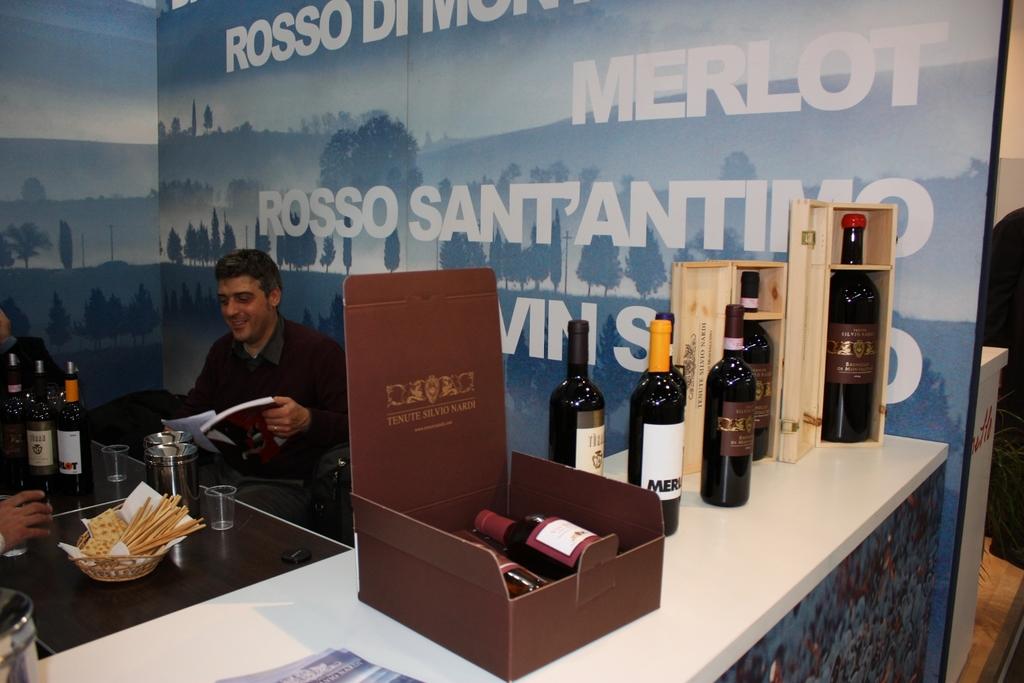What is the name of the wine in the box?
Your answer should be compact. Unanswerable. What kind of wine is on the poster?
Make the answer very short. Merlot. 